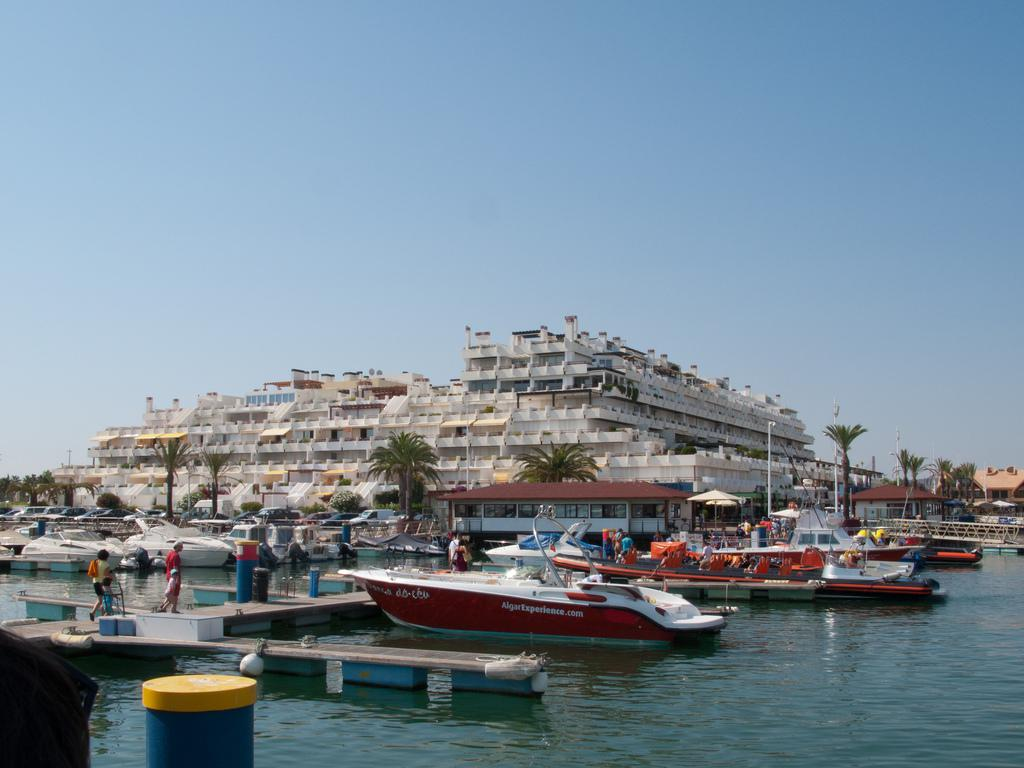Question: when was the photo taken?
Choices:
A. At night.
B. During the day.
C. Last year.
D. During a thunder storm.
Answer with the letter. Answer: B Question: why are the boats lined up?
Choices:
A. They are in a marina.
B. They are getting ready to set sail.
C. They are in a parade.
D. They are waiting to be serviced.
Answer with the letter. Answer: A Question: how did the people get to the boats that are in the water?
Choices:
A. By riding in a dinghy.
B. By swimming.
C. By taking another boat.
D. By walking on a wooden plank platform.
Answer with the letter. Answer: D Question: who are the last two people in the photo, walking on the plank?
Choices:
A. An adult female with a yellow shirt and a child with blue shorts.
B. A man with black pants.
C. A girl with green shoes.
D. A woman with dark hair.
Answer with the letter. Answer: A Question: what color is the top on the pole that is closeup in the photo?
Choices:
A. Yellow.
B. Red.
C. Green.
D. Orange.
Answer with the letter. Answer: A Question: what is the sky like?
Choices:
A. Bright and clear.
B. Pale with no clouds.
C. Sunny and cloudy.
D. Dark and rainy.
Answer with the letter. Answer: B Question: what kind of day is it?
Choices:
A. Dark and dreary.
B. Rainy and cloudy.
C. Bright and sunny.
D. Depressing.
Answer with the letter. Answer: C Question: what is a pier filled with?
Choices:
A. Boats and people.
B. Umbrellas.
C. Swimmers.
D. Vacationers.
Answer with the letter. Answer: A Question: what is in the background?
Choices:
A. A parking lot.
B. Large building.
C. A number of pedestrians.
D. A large sign.
Answer with the letter. Answer: B Question: what color is one of the boats?
Choices:
A. Purple.
B. Grey.
C. Orange.
D. Red and white.
Answer with the letter. Answer: D Question: what have been planted at the waterfront?
Choices:
A. Beach umbrellas.
B. People's seats.
C. Palm trees.
D. Flora.
Answer with the letter. Answer: C Question: what kind of trees are in the distance?
Choices:
A. There are oak trees in the distance.
B. I'm uncertain what trees are growing in the distance.
C. Can you see that far.
D. Palm trees are in the distance.
Answer with the letter. Answer: D Question: what color is the man on the pier wearing?
Choices:
A. The man is wearing a red shirt.
B. The man is wearing a yellow shirt.
C. The man is wearing a green shirt.
D. The man is wearing a pink shirt.
Answer with the letter. Answer: A Question: what color lettering is on the red boat?
Choices:
A. The red boat has green lettering.
B. The red boat has white lettering.
C. The red boat has purple lettering.
D. The red boat has black lettering.
Answer with the letter. Answer: B Question: what has blue barrels under it?
Choices:
A. A houseboat.
B. A landfill.
C. A landing.
D. A doc.
Answer with the letter. Answer: D Question: how many clouds are in the sky?
Choices:
A. None.
B. One.
C. Two.
D. Three.
Answer with the letter. Answer: A Question: how many different rows are the boats lined up?
Choices:
A. 2.
B. 1.
C. 3.
D. 4.
Answer with the letter. Answer: A Question: where are the people?
Choices:
A. On the dock.
B. On the harbor.
C. On the beach.
D. On the boat.
Answer with the letter. Answer: B Question: what color are the light poles in front of boats?
Choices:
A. Brown.
B. White.
C. Silver.
D. Black.
Answer with the letter. Answer: B 